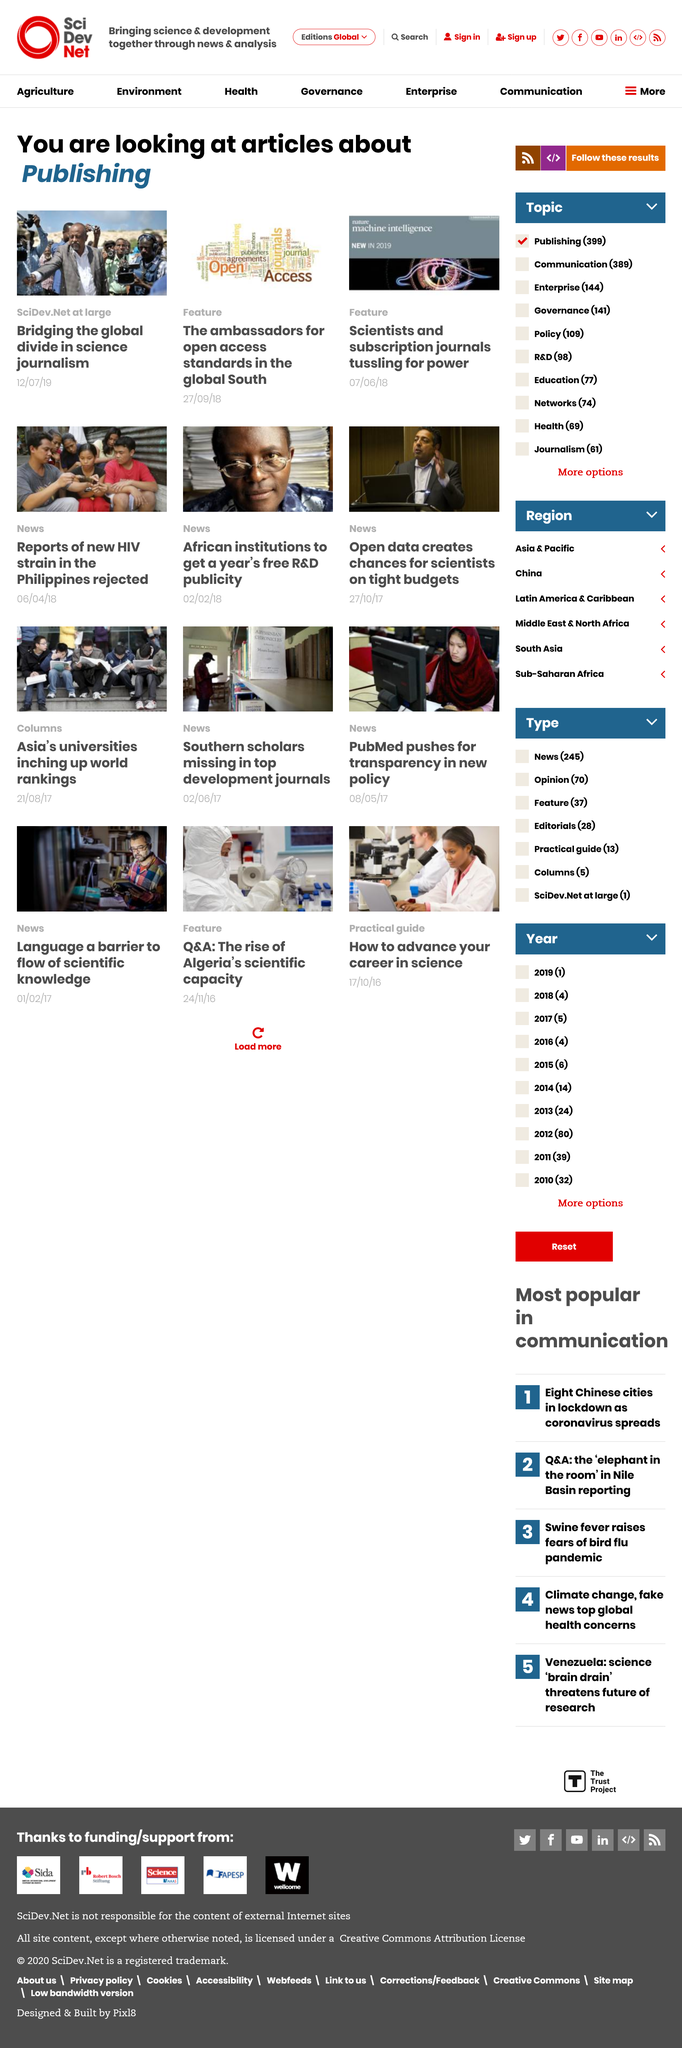Indicate a few pertinent items in this graphic. Power struggles between scientists and subscription journals are taking place. There are a total of three featured articles. The articles pertain to the act of publishing. 